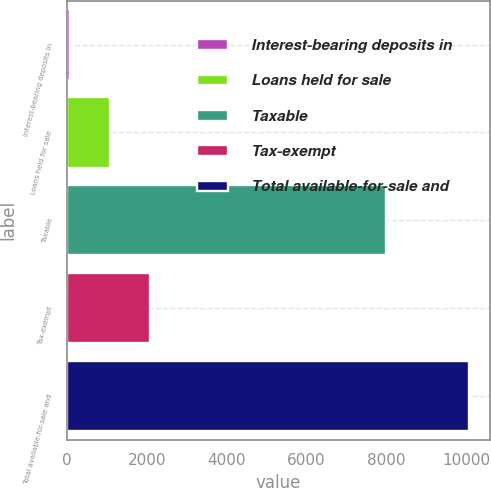Convert chart to OTSL. <chart><loc_0><loc_0><loc_500><loc_500><bar_chart><fcel>Interest-bearing deposits in<fcel>Loans held for sale<fcel>Taxable<fcel>Tax-exempt<fcel>Total available-for-sale and<nl><fcel>90<fcel>1088.4<fcel>7999<fcel>2086.8<fcel>10074<nl></chart> 